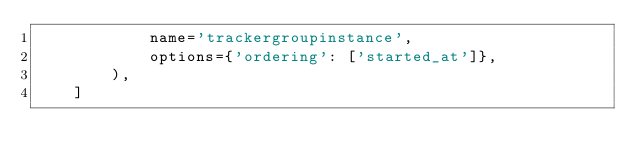Convert code to text. <code><loc_0><loc_0><loc_500><loc_500><_Python_>            name='trackergroupinstance',
            options={'ordering': ['started_at']},
        ),
    ]
</code> 